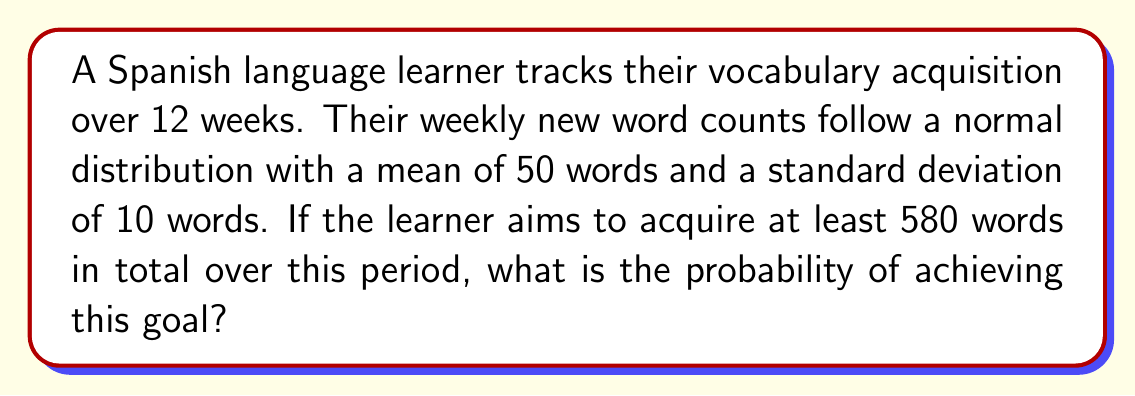Could you help me with this problem? Let's approach this step-by-step:

1) First, we need to find the total number of words expected to be learned over 12 weeks:
   $\mu_{total} = 12 \times 50 = 600$ words

2) The standard deviation for the total words learned over 12 weeks is:
   $\sigma_{total} = \sqrt{12} \times 10 = \sqrt{1200} \approx 34.64$ words

3) We want to find the probability of learning at least 580 words. We can use the z-score to standardize this value:

   $$z = \frac{x - \mu}{\sigma} = \frac{580 - 600}{34.64} \approx -0.5774$$

4) Now, we need to find the probability of Z being greater than -0.5774. This is equivalent to:

   $$P(Z > -0.5774) = 1 - P(Z < -0.5774)$$

5) Using a standard normal distribution table or calculator:

   $$P(Z < -0.5774) \approx 0.2819$$

6) Therefore:

   $$P(Z > -0.5774) = 1 - 0.2819 = 0.7181$$

Thus, the probability of learning at least 580 words in 12 weeks is approximately 0.7181 or 71.81%.
Answer: 0.7181 